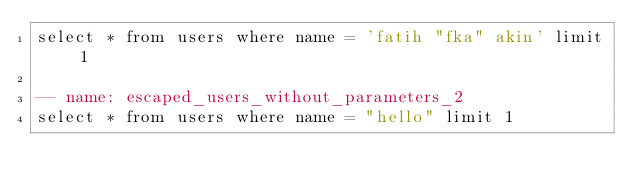Convert code to text. <code><loc_0><loc_0><loc_500><loc_500><_SQL_>select * from users where name = 'fatih "fka" akin' limit 1

-- name: escaped_users_without_parameters_2
select * from users where name = "hello" limit 1</code> 